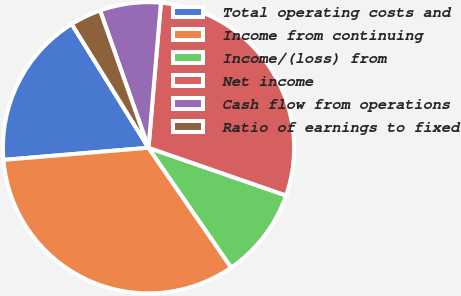<chart> <loc_0><loc_0><loc_500><loc_500><pie_chart><fcel>Total operating costs and<fcel>Income from continuing<fcel>Income/(loss) from<fcel>Net income<fcel>Cash flow from operations<fcel>Ratio of earnings to fixed<nl><fcel>17.49%<fcel>33.29%<fcel>10.07%<fcel>28.95%<fcel>6.76%<fcel>3.44%<nl></chart> 